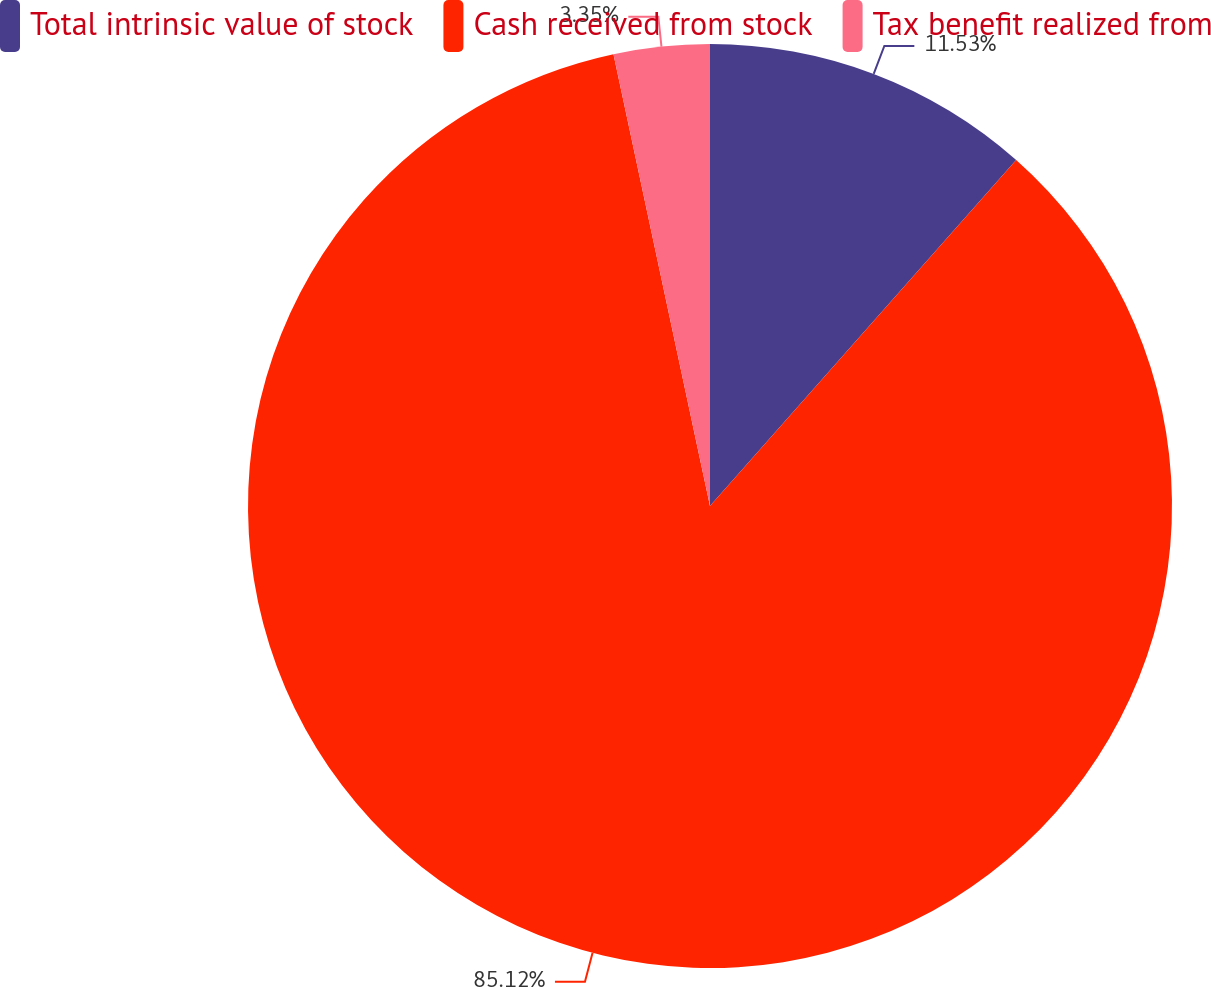<chart> <loc_0><loc_0><loc_500><loc_500><pie_chart><fcel>Total intrinsic value of stock<fcel>Cash received from stock<fcel>Tax benefit realized from<nl><fcel>11.53%<fcel>85.12%<fcel>3.35%<nl></chart> 